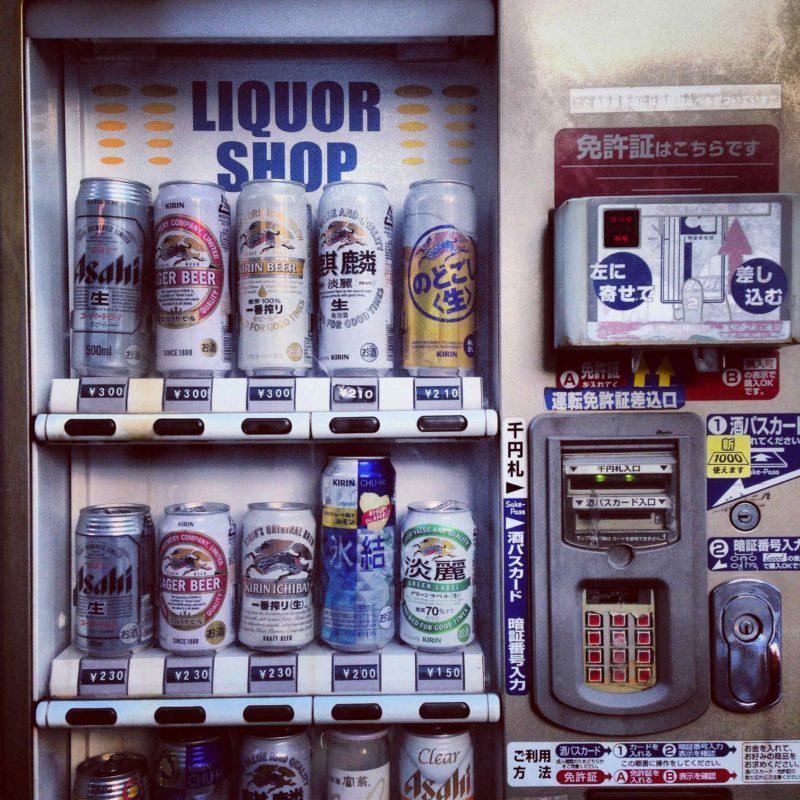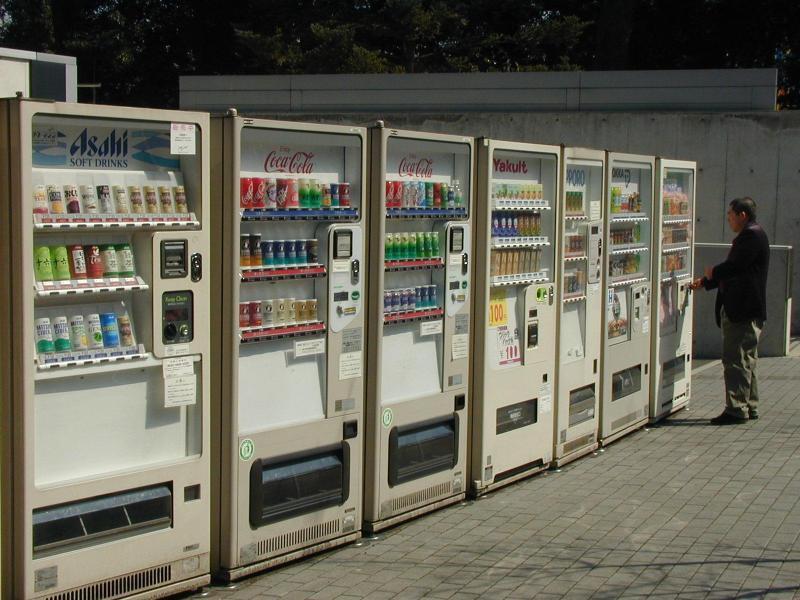The first image is the image on the left, the second image is the image on the right. For the images shown, is this caption "There are at least three vending machines that have blue casing." true? Answer yes or no. No. The first image is the image on the left, the second image is the image on the right. For the images displayed, is the sentence "An image shows a row of red, white and blue vending machines." factually correct? Answer yes or no. No. 